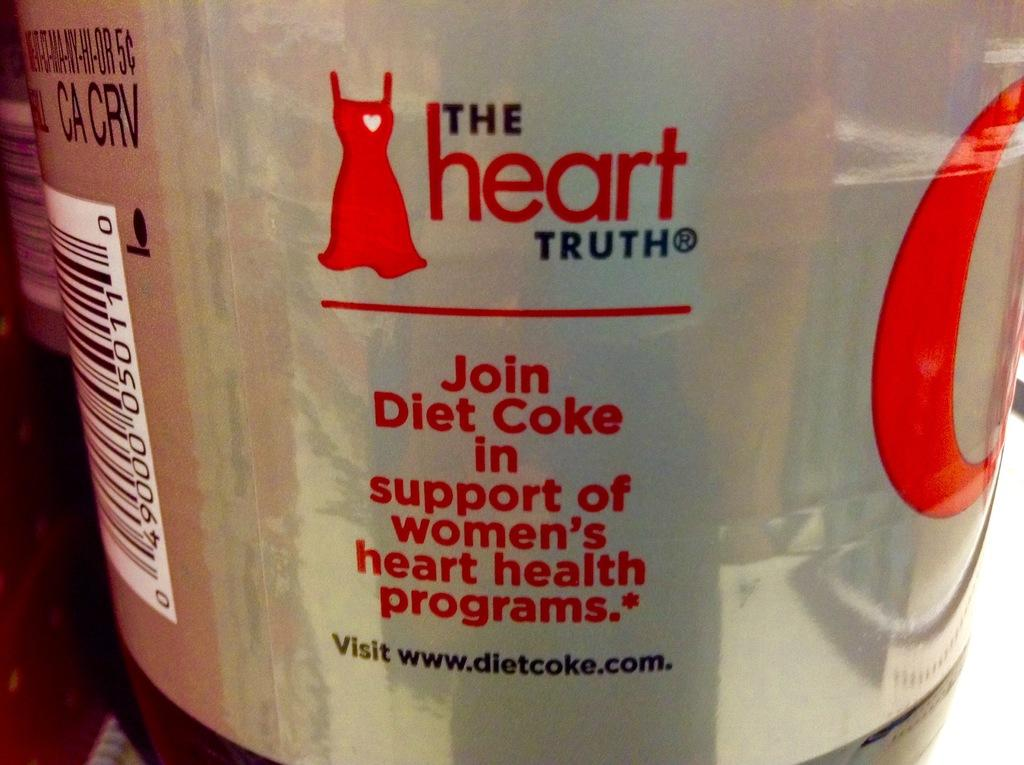<image>
Create a compact narrative representing the image presented. A can of Diet Coke with the slogan "The Heart Truth". 